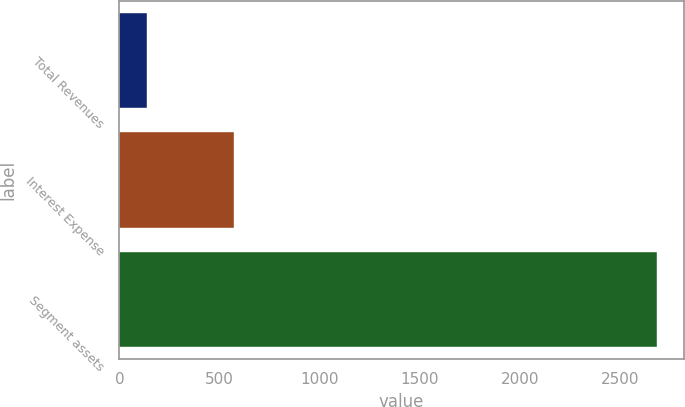<chart> <loc_0><loc_0><loc_500><loc_500><bar_chart><fcel>Total Revenues<fcel>Interest Expense<fcel>Segment assets<nl><fcel>138<fcel>574<fcel>2685<nl></chart> 